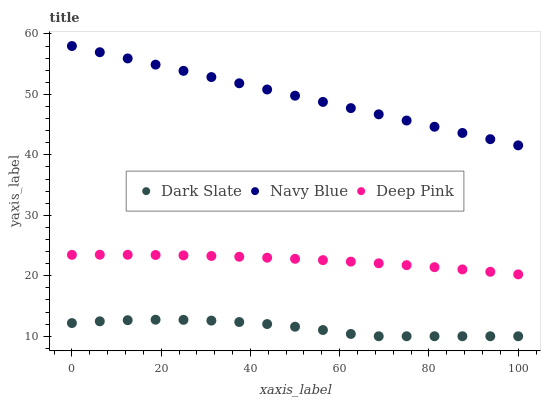Does Dark Slate have the minimum area under the curve?
Answer yes or no. Yes. Does Navy Blue have the maximum area under the curve?
Answer yes or no. Yes. Does Deep Pink have the minimum area under the curve?
Answer yes or no. No. Does Deep Pink have the maximum area under the curve?
Answer yes or no. No. Is Navy Blue the smoothest?
Answer yes or no. Yes. Is Dark Slate the roughest?
Answer yes or no. Yes. Is Deep Pink the smoothest?
Answer yes or no. No. Is Deep Pink the roughest?
Answer yes or no. No. Does Dark Slate have the lowest value?
Answer yes or no. Yes. Does Deep Pink have the lowest value?
Answer yes or no. No. Does Navy Blue have the highest value?
Answer yes or no. Yes. Does Deep Pink have the highest value?
Answer yes or no. No. Is Dark Slate less than Deep Pink?
Answer yes or no. Yes. Is Deep Pink greater than Dark Slate?
Answer yes or no. Yes. Does Dark Slate intersect Deep Pink?
Answer yes or no. No. 